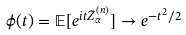Convert formula to latex. <formula><loc_0><loc_0><loc_500><loc_500>\phi ( t ) = \mathbb { E } [ e ^ { i t \tilde { Z } _ { \alpha } ^ { ( n ) } } ] \to e ^ { - t ^ { 2 } / 2 }</formula> 